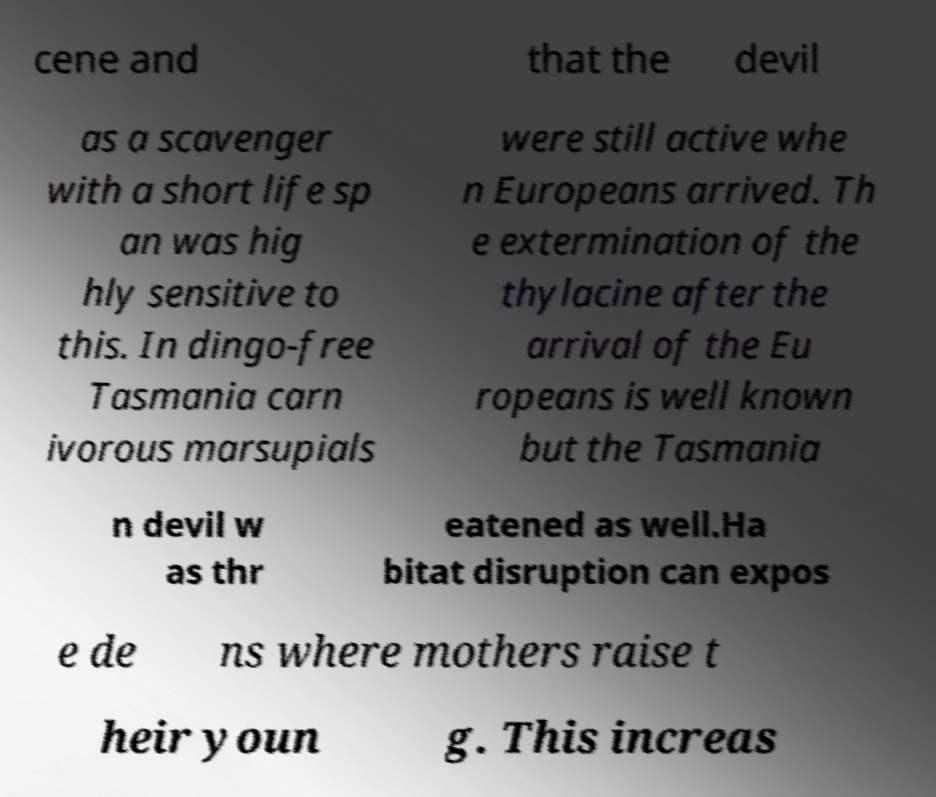What messages or text are displayed in this image? I need them in a readable, typed format. cene and that the devil as a scavenger with a short life sp an was hig hly sensitive to this. In dingo-free Tasmania carn ivorous marsupials were still active whe n Europeans arrived. Th e extermination of the thylacine after the arrival of the Eu ropeans is well known but the Tasmania n devil w as thr eatened as well.Ha bitat disruption can expos e de ns where mothers raise t heir youn g. This increas 